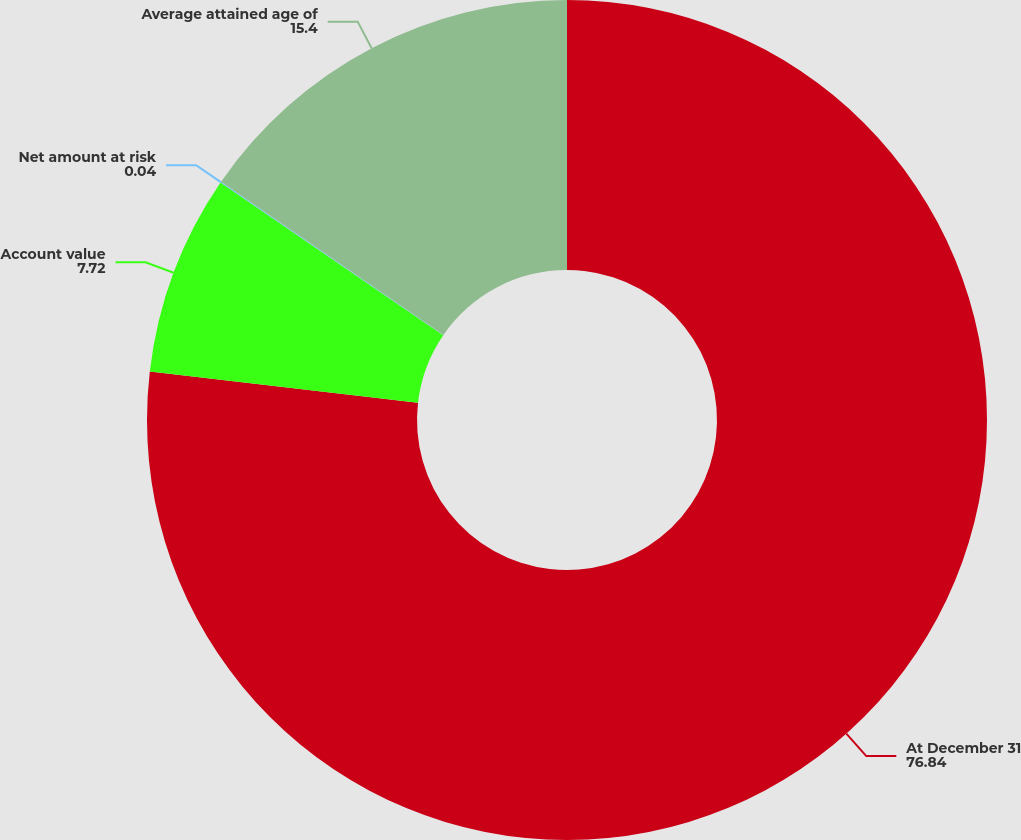Convert chart. <chart><loc_0><loc_0><loc_500><loc_500><pie_chart><fcel>At December 31<fcel>Account value<fcel>Net amount at risk<fcel>Average attained age of<nl><fcel>76.84%<fcel>7.72%<fcel>0.04%<fcel>15.4%<nl></chart> 